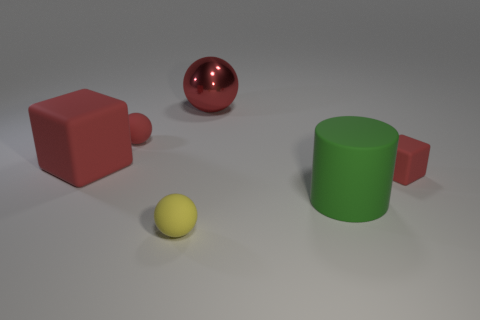Is there a big green rubber thing that has the same shape as the small yellow rubber thing?
Ensure brevity in your answer.  No. There is a red matte object that is the same size as the green rubber cylinder; what shape is it?
Your answer should be compact. Cube. What number of objects are red rubber blocks to the left of the small yellow rubber sphere or red balls?
Your answer should be compact. 3. Do the large metal sphere and the big block have the same color?
Keep it short and to the point. Yes. What size is the red thing to the right of the big metallic object?
Provide a succinct answer. Small. Is there a purple object of the same size as the green matte cylinder?
Ensure brevity in your answer.  No. There is a rubber block that is to the left of the red rubber ball; is its size the same as the metallic object?
Provide a short and direct response. Yes. The shiny ball is what size?
Offer a terse response. Large. What is the color of the rubber block that is on the right side of the tiny matte sphere that is behind the tiny object that is on the right side of the large green cylinder?
Offer a very short reply. Red. Does the big matte object that is behind the large green matte object have the same color as the large metal ball?
Offer a terse response. Yes. 